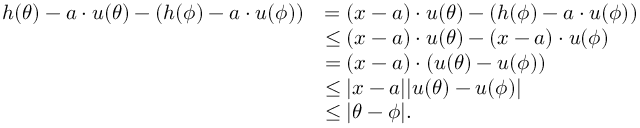<formula> <loc_0><loc_0><loc_500><loc_500>\begin{array} { r l } { h ( \theta ) - a \cdot u ( \theta ) - ( h ( \phi ) - a \cdot u ( \phi ) ) } & { = ( x - a ) \cdot u ( \theta ) - ( h ( \phi ) - a \cdot u ( \phi ) ) } \\ & { \leq ( x - a ) \cdot u ( \theta ) - ( x - a ) \cdot u ( \phi ) } \\ & { = ( x - a ) \cdot ( u ( \theta ) - u ( \phi ) ) } \\ & { \leq | x - a | | u ( \theta ) - u ( \phi ) | } \\ & { \leq | \theta - \phi | . } \end{array}</formula> 